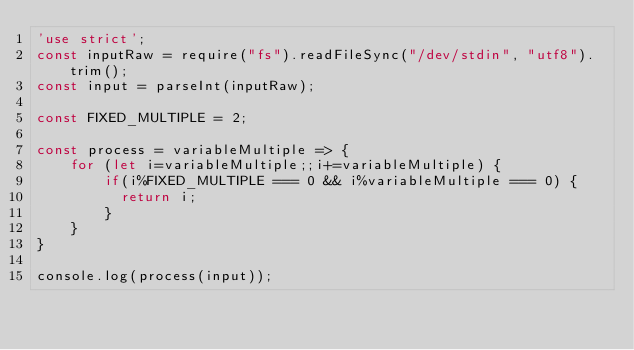<code> <loc_0><loc_0><loc_500><loc_500><_JavaScript_>'use strict';
const inputRaw = require("fs").readFileSync("/dev/stdin", "utf8").trim();
const input = parseInt(inputRaw);

const FIXED_MULTIPLE = 2;

const process = variableMultiple => {
    for (let i=variableMultiple;;i+=variableMultiple) {
        if(i%FIXED_MULTIPLE === 0 && i%variableMultiple === 0) {
          return i;
        }
    }
}

console.log(process(input));</code> 